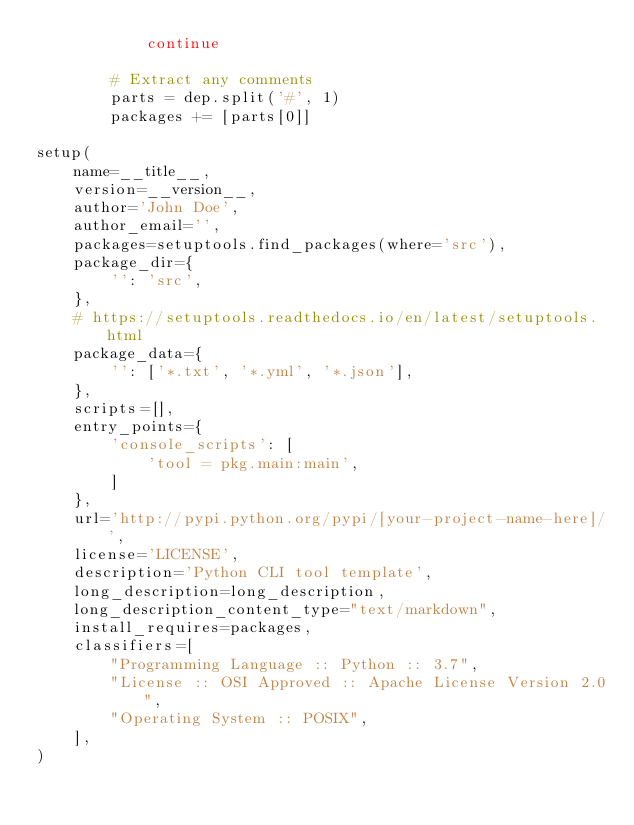Convert code to text. <code><loc_0><loc_0><loc_500><loc_500><_Python_>            continue

        # Extract any comments
        parts = dep.split('#', 1)
        packages += [parts[0]]

setup(
    name=__title__,
    version=__version__,
    author='John Doe',
    author_email='',
    packages=setuptools.find_packages(where='src'),
    package_dir={
        '': 'src',
    },
    # https://setuptools.readthedocs.io/en/latest/setuptools.html
    package_data={
        '': ['*.txt', '*.yml', '*.json'],
    },
    scripts=[],
    entry_points={
        'console_scripts': [
            'tool = pkg.main:main',
        ]
    },
    url='http://pypi.python.org/pypi/[your-project-name-here]/',
    license='LICENSE',
    description='Python CLI tool template',
    long_description=long_description,
    long_description_content_type="text/markdown",
    install_requires=packages,
    classifiers=[
        "Programming Language :: Python :: 3.7",
        "License :: OSI Approved :: Apache License Version 2.0",
        "Operating System :: POSIX",
    ],
)
</code> 